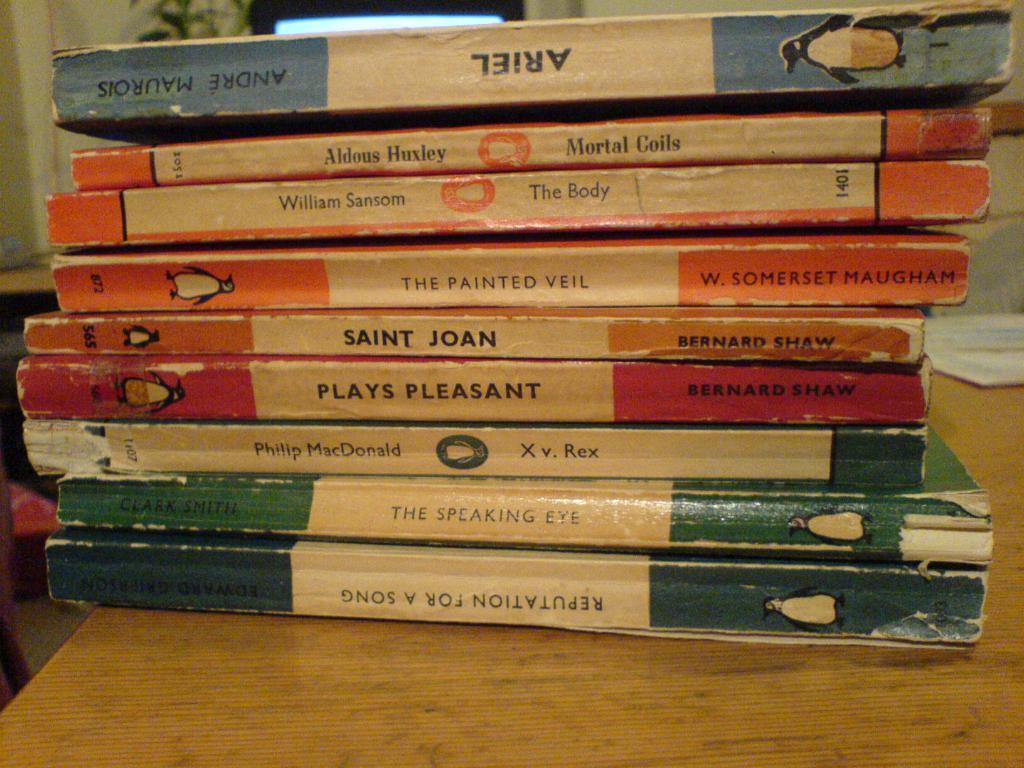How would you summarize this image in a sentence or two? We can see books on the table. In the background we can see green leaves and wall. 